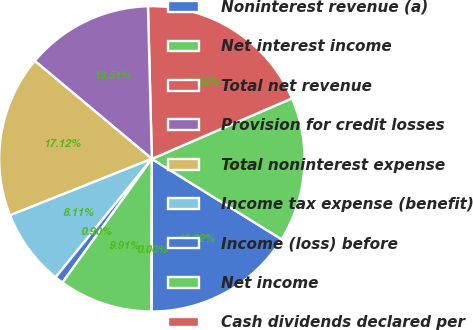<chart> <loc_0><loc_0><loc_500><loc_500><pie_chart><fcel>Noninterest revenue (a)<fcel>Net interest income<fcel>Total net revenue<fcel>Provision for credit losses<fcel>Total noninterest expense<fcel>Income tax expense (benefit)<fcel>Income (loss) before<fcel>Net income<fcel>Cash dividends declared per<nl><fcel>16.22%<fcel>15.32%<fcel>18.92%<fcel>13.51%<fcel>17.12%<fcel>8.11%<fcel>0.9%<fcel>9.91%<fcel>0.0%<nl></chart> 